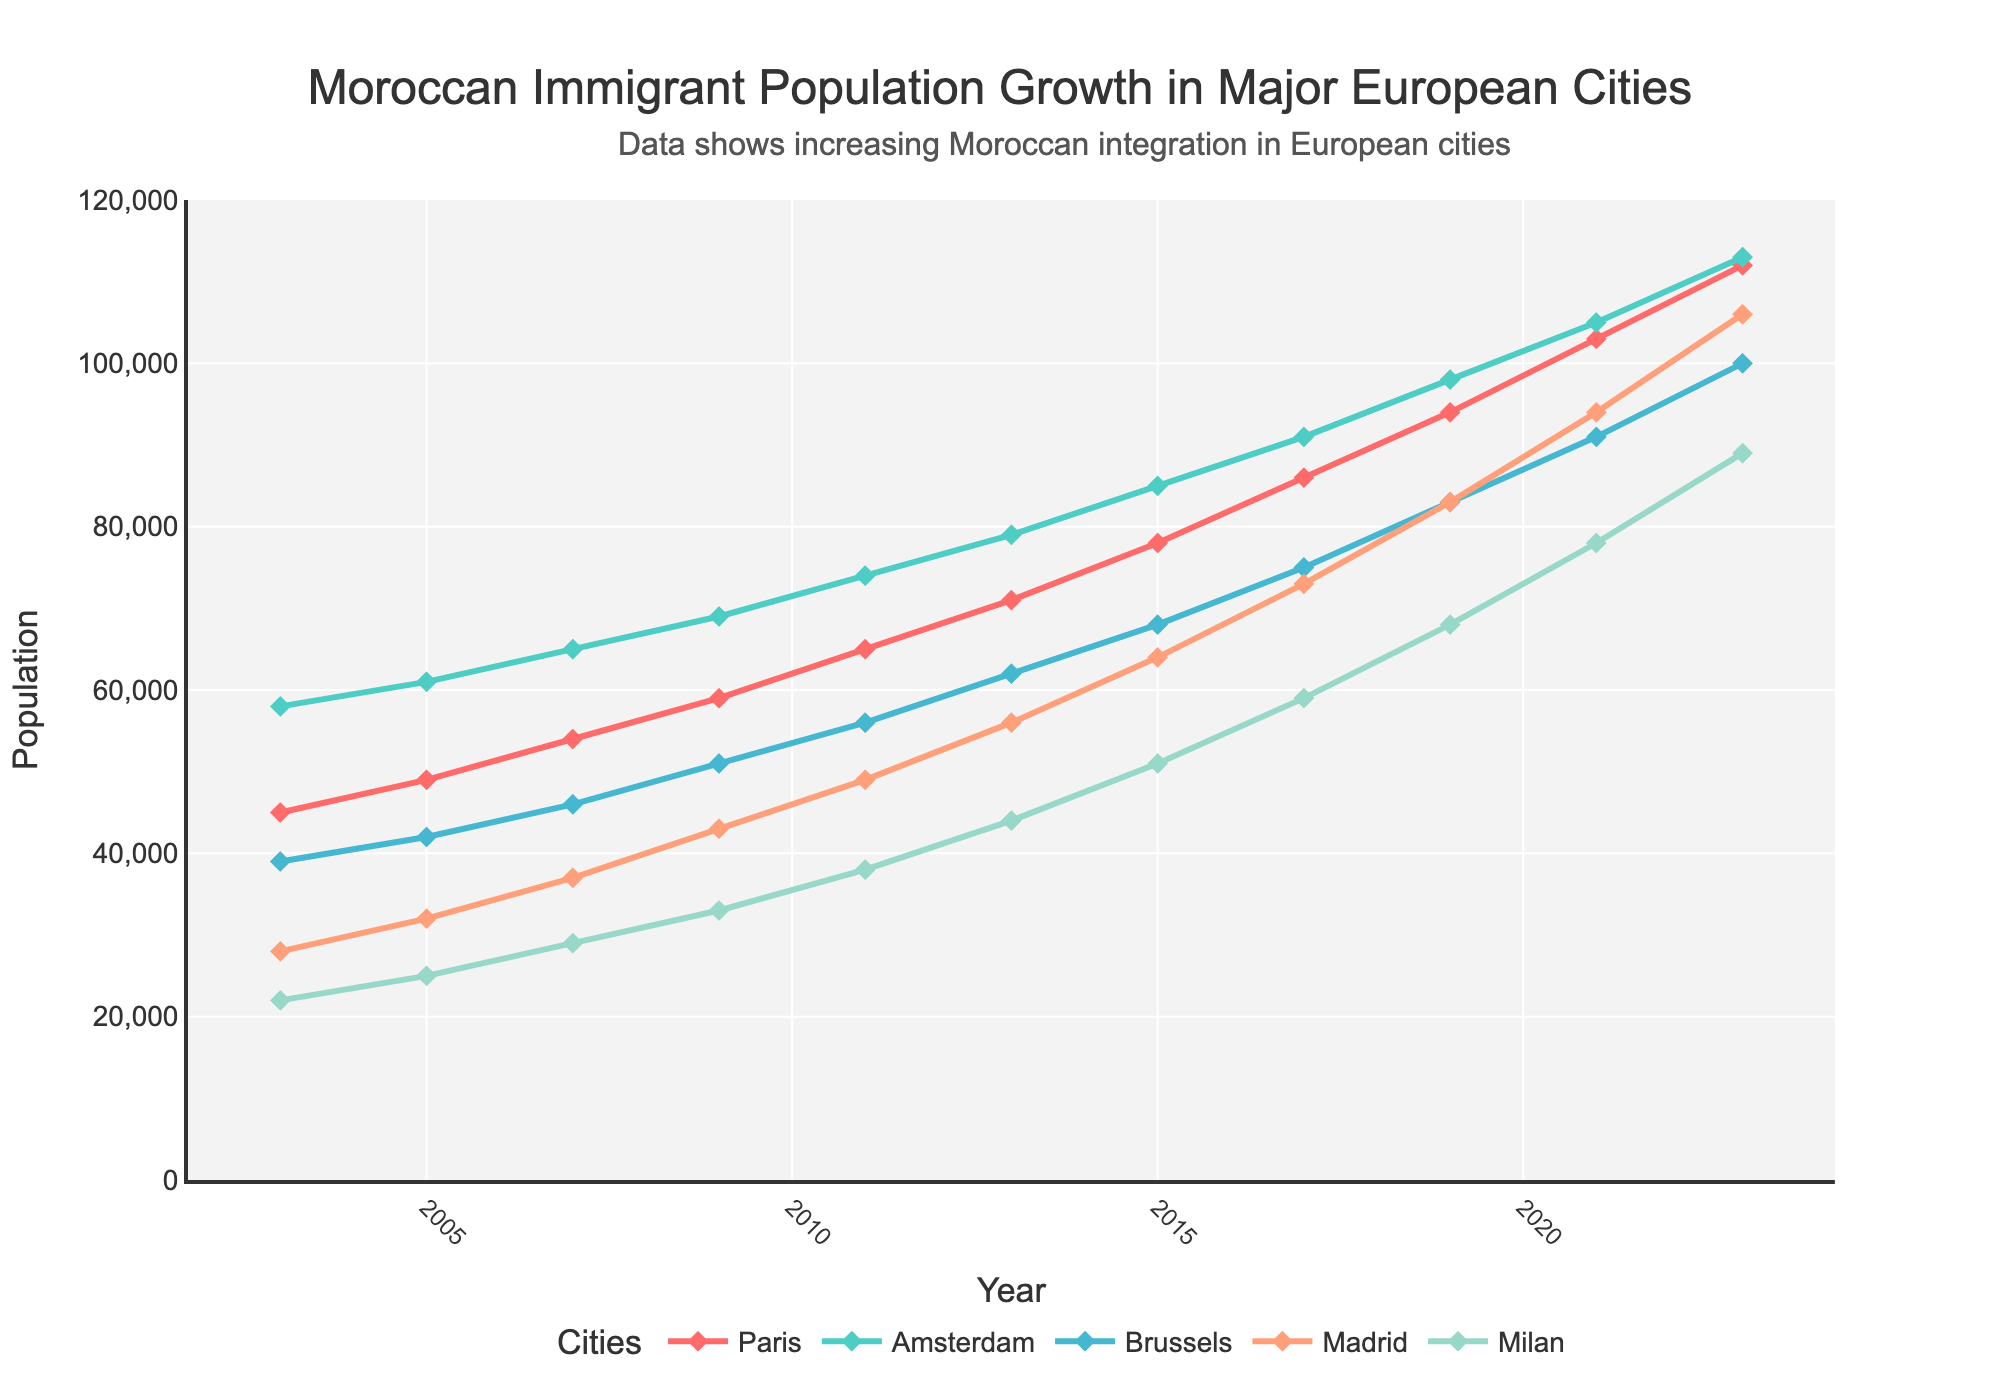What is the population growth of Moroccan immigrants in Paris from 2003 to 2023? To find the population growth in Paris from 2003 to 2023, subtract the population in 2003 from the population in 2023. The population in Paris in 2003 was 45,000, and in 2023 it was 112,000. So, 112,000 - 45,000 = 67,000.
Answer: 67,000 How many cities had a Moroccan immigrant population greater than 100,000 in 2023? In 2023, the populations are Paris (112,000), Amsterdam (113,000), Brussels (100,000), Madrid (106,000), and Milan (89,000). Only Paris, Amsterdam, Brussels, and Madrid had populations greater than 100,000.
Answer: 4 Which city had the smallest Moroccan immigrant population in 2003? Look at the population values for 2003: Paris (45,000), Amsterdam (58,000), Brussels (39,000), Madrid (28,000), and Milan (22,000). Milan had the smallest population at 22,000.
Answer: Milan What is the average Moroccan immigrant population in Madrid from 2003 to 2023? To find the average, sum the populations from each year and divide by the number of years (11 years). The populations are: 28,000, 32,000, 37,000, 43,000, 49,000, 56,000, 64,000, 73,000, 83,000, 94,000, 106,000. Sum = 665,000. Average = 665,000 / 11 = 60,455.
Answer: 60,455 Between 2003 and 2023, which city's Moroccan immigrant population increased the most? Calculate the difference between 2023 and 2003 populations for each city: Paris (112,000 - 45,000 = 67,000), Amsterdam (113,000 - 58,000 = 55,000), Brussels (100,000 - 39,000 = 61,000), Madrid (106,000 - 28,000 = 78,000), Milan (89,000 - 22,000 = 67,000). Madrid had the highest increase with 78,000.
Answer: Madrid In which year did Brussels surpass 50,000 Moroccan immigrants? Look at the population for Brussels over the years. In 2009, the population was 51,000, which is the first occurrence above 50,000.
Answer: 2009 Compare the change in population between 2009 and 2019 for Paris and Milan. Which city had a higher growth? Calculate the growth from 2009 to 2019: Paris (94,000 - 59,000 = 35,000), Milan (68,000 - 33,000 = 35,000). Both cities had the same growth of 35,000.
Answer: Both Which city had the most consistent growth in Moroccan immigrant population from 2003 to 2023? Looking at the linearity of the population growth curves, Amsterdam shows the most consistent and steady increase.
Answer: Amsterdam What year did Amsterdam's Moroccan immigrant population reach 90,000? Look at the population for Amsterdam over the years. In 2017, the population was 91,000, which is the first occurrence above 90,000.
Answer: 2017 